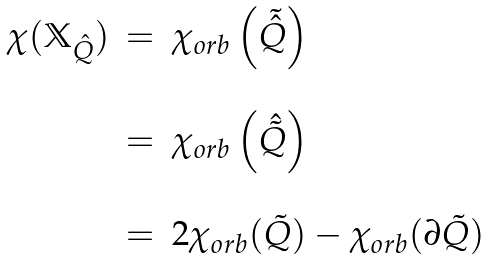<formula> <loc_0><loc_0><loc_500><loc_500>\begin{array} { r c l } \chi ( \mathbb { X } _ { \hat { Q } } ) & = & \chi _ { o r b } \left ( \tilde { \hat { Q } } \right ) \\ \\ & = & \chi _ { o r b } \left ( \hat { \tilde { Q } } \right ) \\ \\ & = & 2 \chi _ { o r b } ( \tilde { Q } ) - \chi _ { o r b } ( \partial \tilde { Q } ) \end{array}</formula> 